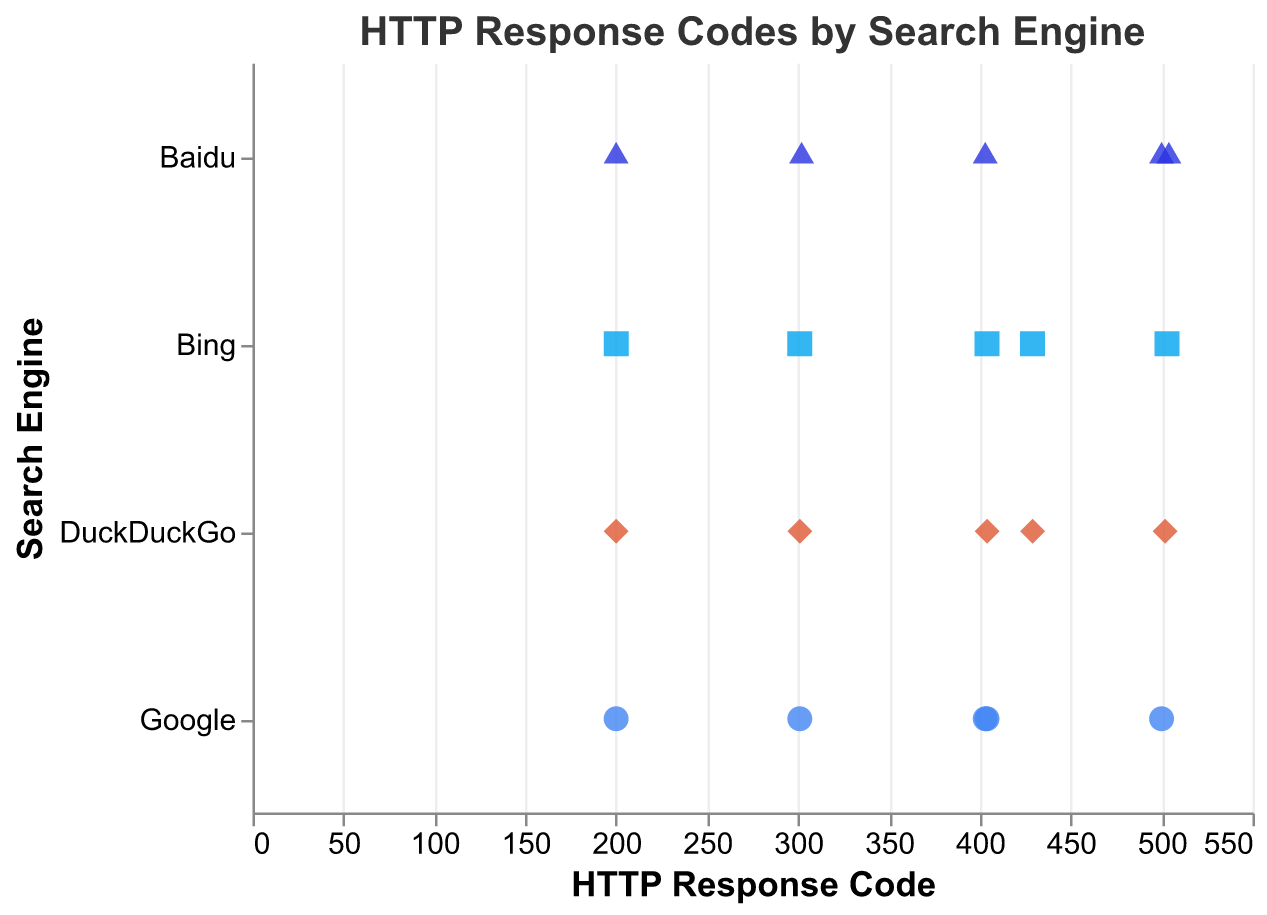What is the title of the strip plot? The title of the strip plot is located at the top and it states, "HTTP Response Codes by Search Engine".
Answer: HTTP Response Codes by Search Engine Which search engine has encountered the '404' response code? By looking at the y-axis labeled "Search Engine" and the data points along the x-axis at '404', we see that Google, Bing, and DuckDuckGo have encountered the '404' response code.
Answer: Google, Bing, DuckDuckGo How many unique response codes does Bing encounter? Bing encounters five unique response codes as observed from the data points associated with Bing on the y-axis: 200, 301, 404, 503, 429.
Answer: 5 Which search engine has the maximum response code value and what is it? By inspecting the data points along the x-axis, we see that Baidu has the highest response code value at 504.
Answer: Baidu, 504 How many search engines encountered a '403' response code? By looking at the x-axis for '403' response codes and seeing which search engines are aligned with it along the y-axis, we identify that Google and Baidu encountered a '403' response code.
Answer: 2 (Google, Baidu) What is the most common response code encountered by search engines in the dataset? The most common response code can be identified by seeing which x-axis value has the maximum number of corresponding data points. The response code '200' appears most frequently, being encountered by all four search engines.
Answer: 200 Which search engine encountered the widest range of response codes? To determine this, observe each search engine and count their unique response codes shown along the x-axis. Both Bing and Baidu encounter five unique response codes, so they have the widest range.
Answer: Bing, Baidu Comparing the search engines, which search engine encountered the least problematic response codes (excluding 4xx and 5xx codes)? By excluding 4xx and 5xx response codes (which indicate client and server errors), and looking at the remaining response codes (200, 301, 302), we see:
Google: 200, 301
Bing: 200, 301
Baidu: 200, 302
DuckDuckGo: 200, 301
Baidu encountered 302, considered as less problematic, more than others.
Answer: Baidu What shapes are used to represent each search engine in the strip plot? The shapes are determined by looking at the legend detailing search engines: Google is represented by circles, Bing by squares, Baidu by triangles, and DuckDuckGo by diamonds.
Answer: Google: circle, Bing: square, Baidu: triangle, DuckDuckGo: diamond 